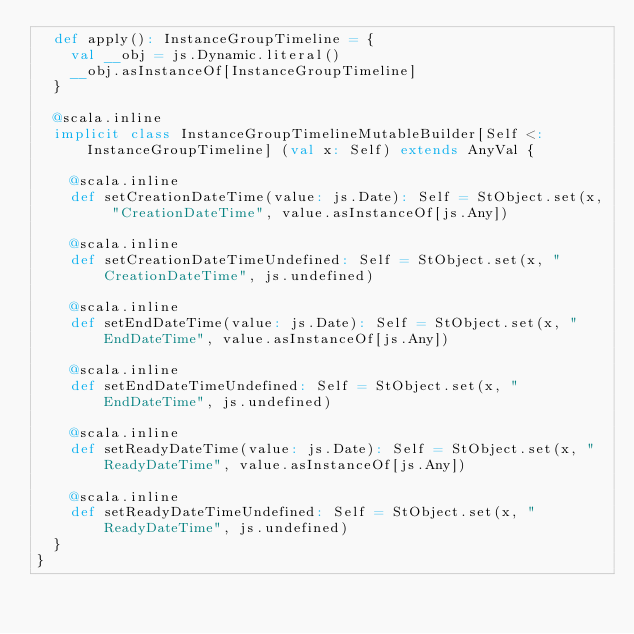Convert code to text. <code><loc_0><loc_0><loc_500><loc_500><_Scala_>  def apply(): InstanceGroupTimeline = {
    val __obj = js.Dynamic.literal()
    __obj.asInstanceOf[InstanceGroupTimeline]
  }
  
  @scala.inline
  implicit class InstanceGroupTimelineMutableBuilder[Self <: InstanceGroupTimeline] (val x: Self) extends AnyVal {
    
    @scala.inline
    def setCreationDateTime(value: js.Date): Self = StObject.set(x, "CreationDateTime", value.asInstanceOf[js.Any])
    
    @scala.inline
    def setCreationDateTimeUndefined: Self = StObject.set(x, "CreationDateTime", js.undefined)
    
    @scala.inline
    def setEndDateTime(value: js.Date): Self = StObject.set(x, "EndDateTime", value.asInstanceOf[js.Any])
    
    @scala.inline
    def setEndDateTimeUndefined: Self = StObject.set(x, "EndDateTime", js.undefined)
    
    @scala.inline
    def setReadyDateTime(value: js.Date): Self = StObject.set(x, "ReadyDateTime", value.asInstanceOf[js.Any])
    
    @scala.inline
    def setReadyDateTimeUndefined: Self = StObject.set(x, "ReadyDateTime", js.undefined)
  }
}
</code> 